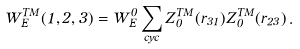<formula> <loc_0><loc_0><loc_500><loc_500>W ^ { T M } _ { E } ( 1 , 2 , 3 ) = W ^ { 0 } _ { E } \sum _ { c y c } Z ^ { T M } _ { 0 } ( r _ { 3 1 } ) Z ^ { T M } _ { 0 } ( r _ { 2 3 } ) \, .</formula> 